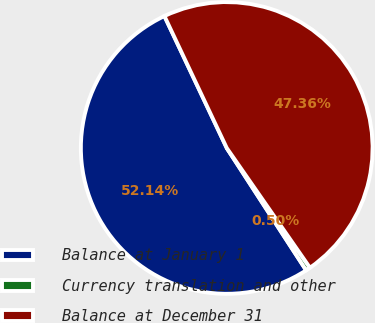Convert chart to OTSL. <chart><loc_0><loc_0><loc_500><loc_500><pie_chart><fcel>Balance at January 1<fcel>Currency translation and other<fcel>Balance at December 31<nl><fcel>52.14%<fcel>0.5%<fcel>47.36%<nl></chart> 